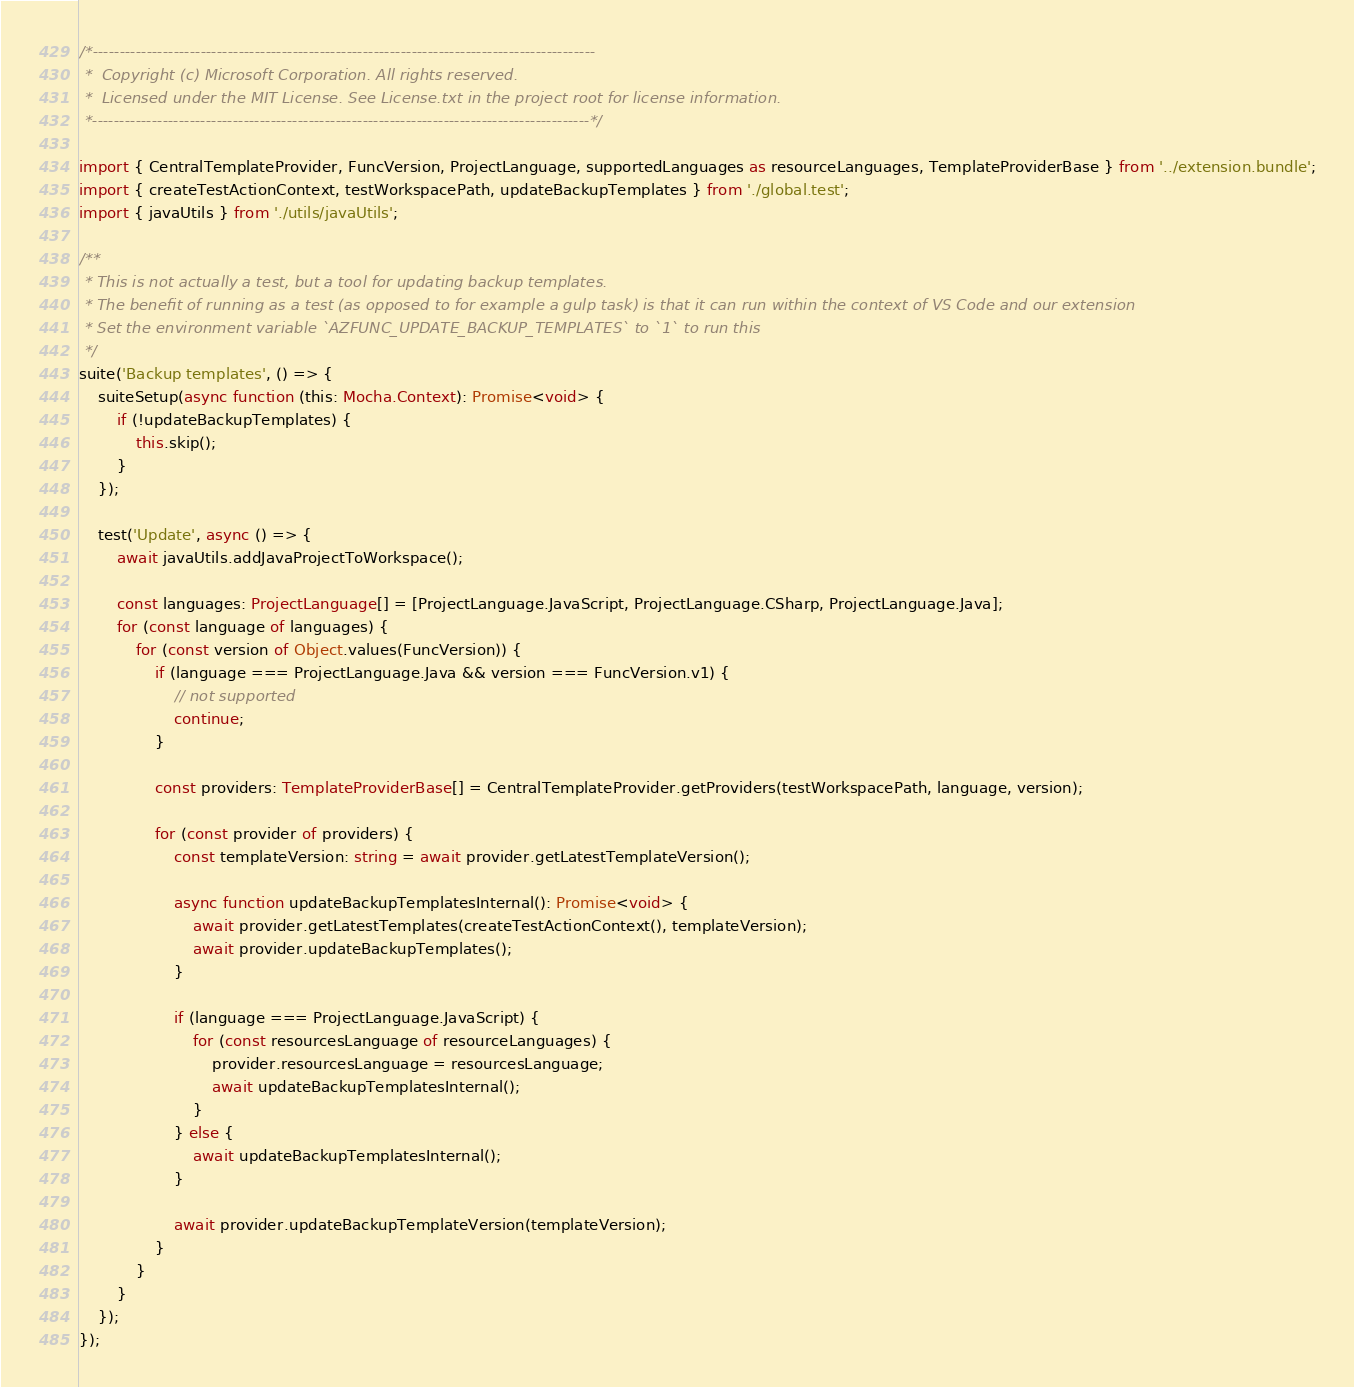Convert code to text. <code><loc_0><loc_0><loc_500><loc_500><_TypeScript_>/*---------------------------------------------------------------------------------------------
 *  Copyright (c) Microsoft Corporation. All rights reserved.
 *  Licensed under the MIT License. See License.txt in the project root for license information.
 *--------------------------------------------------------------------------------------------*/

import { CentralTemplateProvider, FuncVersion, ProjectLanguage, supportedLanguages as resourceLanguages, TemplateProviderBase } from '../extension.bundle';
import { createTestActionContext, testWorkspacePath, updateBackupTemplates } from './global.test';
import { javaUtils } from './utils/javaUtils';

/**
 * This is not actually a test, but a tool for updating backup templates.
 * The benefit of running as a test (as opposed to for example a gulp task) is that it can run within the context of VS Code and our extension
 * Set the environment variable `AZFUNC_UPDATE_BACKUP_TEMPLATES` to `1` to run this
 */
suite('Backup templates', () => {
    suiteSetup(async function (this: Mocha.Context): Promise<void> {
        if (!updateBackupTemplates) {
            this.skip();
        }
    });

    test('Update', async () => {
        await javaUtils.addJavaProjectToWorkspace();

        const languages: ProjectLanguage[] = [ProjectLanguage.JavaScript, ProjectLanguage.CSharp, ProjectLanguage.Java];
        for (const language of languages) {
            for (const version of Object.values(FuncVersion)) {
                if (language === ProjectLanguage.Java && version === FuncVersion.v1) {
                    // not supported
                    continue;
                }

                const providers: TemplateProviderBase[] = CentralTemplateProvider.getProviders(testWorkspacePath, language, version);

                for (const provider of providers) {
                    const templateVersion: string = await provider.getLatestTemplateVersion();

                    async function updateBackupTemplatesInternal(): Promise<void> {
                        await provider.getLatestTemplates(createTestActionContext(), templateVersion);
                        await provider.updateBackupTemplates();
                    }

                    if (language === ProjectLanguage.JavaScript) {
                        for (const resourcesLanguage of resourceLanguages) {
                            provider.resourcesLanguage = resourcesLanguage;
                            await updateBackupTemplatesInternal();
                        }
                    } else {
                        await updateBackupTemplatesInternal();
                    }

                    await provider.updateBackupTemplateVersion(templateVersion);
                }
            }
        }
    });
});
</code> 